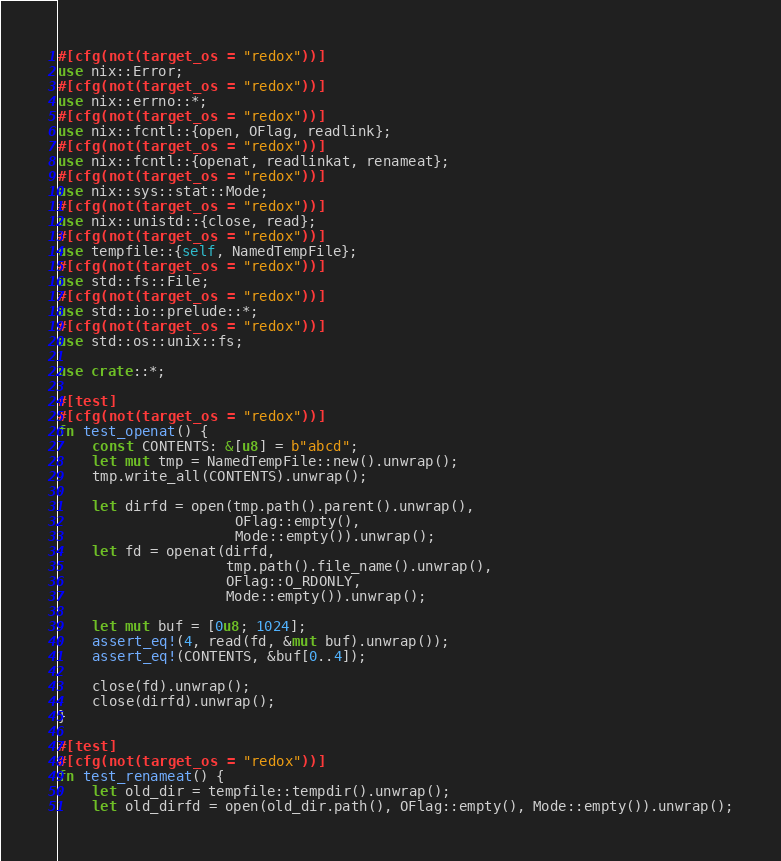Convert code to text. <code><loc_0><loc_0><loc_500><loc_500><_Rust_>#[cfg(not(target_os = "redox"))]
use nix::Error;
#[cfg(not(target_os = "redox"))]
use nix::errno::*;
#[cfg(not(target_os = "redox"))]
use nix::fcntl::{open, OFlag, readlink};
#[cfg(not(target_os = "redox"))]
use nix::fcntl::{openat, readlinkat, renameat};
#[cfg(not(target_os = "redox"))]
use nix::sys::stat::Mode;
#[cfg(not(target_os = "redox"))]
use nix::unistd::{close, read};
#[cfg(not(target_os = "redox"))]
use tempfile::{self, NamedTempFile};
#[cfg(not(target_os = "redox"))]
use std::fs::File;
#[cfg(not(target_os = "redox"))]
use std::io::prelude::*;
#[cfg(not(target_os = "redox"))]
use std::os::unix::fs;

use crate::*;

#[test]
#[cfg(not(target_os = "redox"))]
fn test_openat() {
    const CONTENTS: &[u8] = b"abcd";
    let mut tmp = NamedTempFile::new().unwrap();
    tmp.write_all(CONTENTS).unwrap();

    let dirfd = open(tmp.path().parent().unwrap(),
                     OFlag::empty(),
                     Mode::empty()).unwrap();
    let fd = openat(dirfd,
                    tmp.path().file_name().unwrap(),
                    OFlag::O_RDONLY,
                    Mode::empty()).unwrap();

    let mut buf = [0u8; 1024];
    assert_eq!(4, read(fd, &mut buf).unwrap());
    assert_eq!(CONTENTS, &buf[0..4]);

    close(fd).unwrap();
    close(dirfd).unwrap();
}

#[test]
#[cfg(not(target_os = "redox"))]
fn test_renameat() {
    let old_dir = tempfile::tempdir().unwrap();
    let old_dirfd = open(old_dir.path(), OFlag::empty(), Mode::empty()).unwrap();</code> 